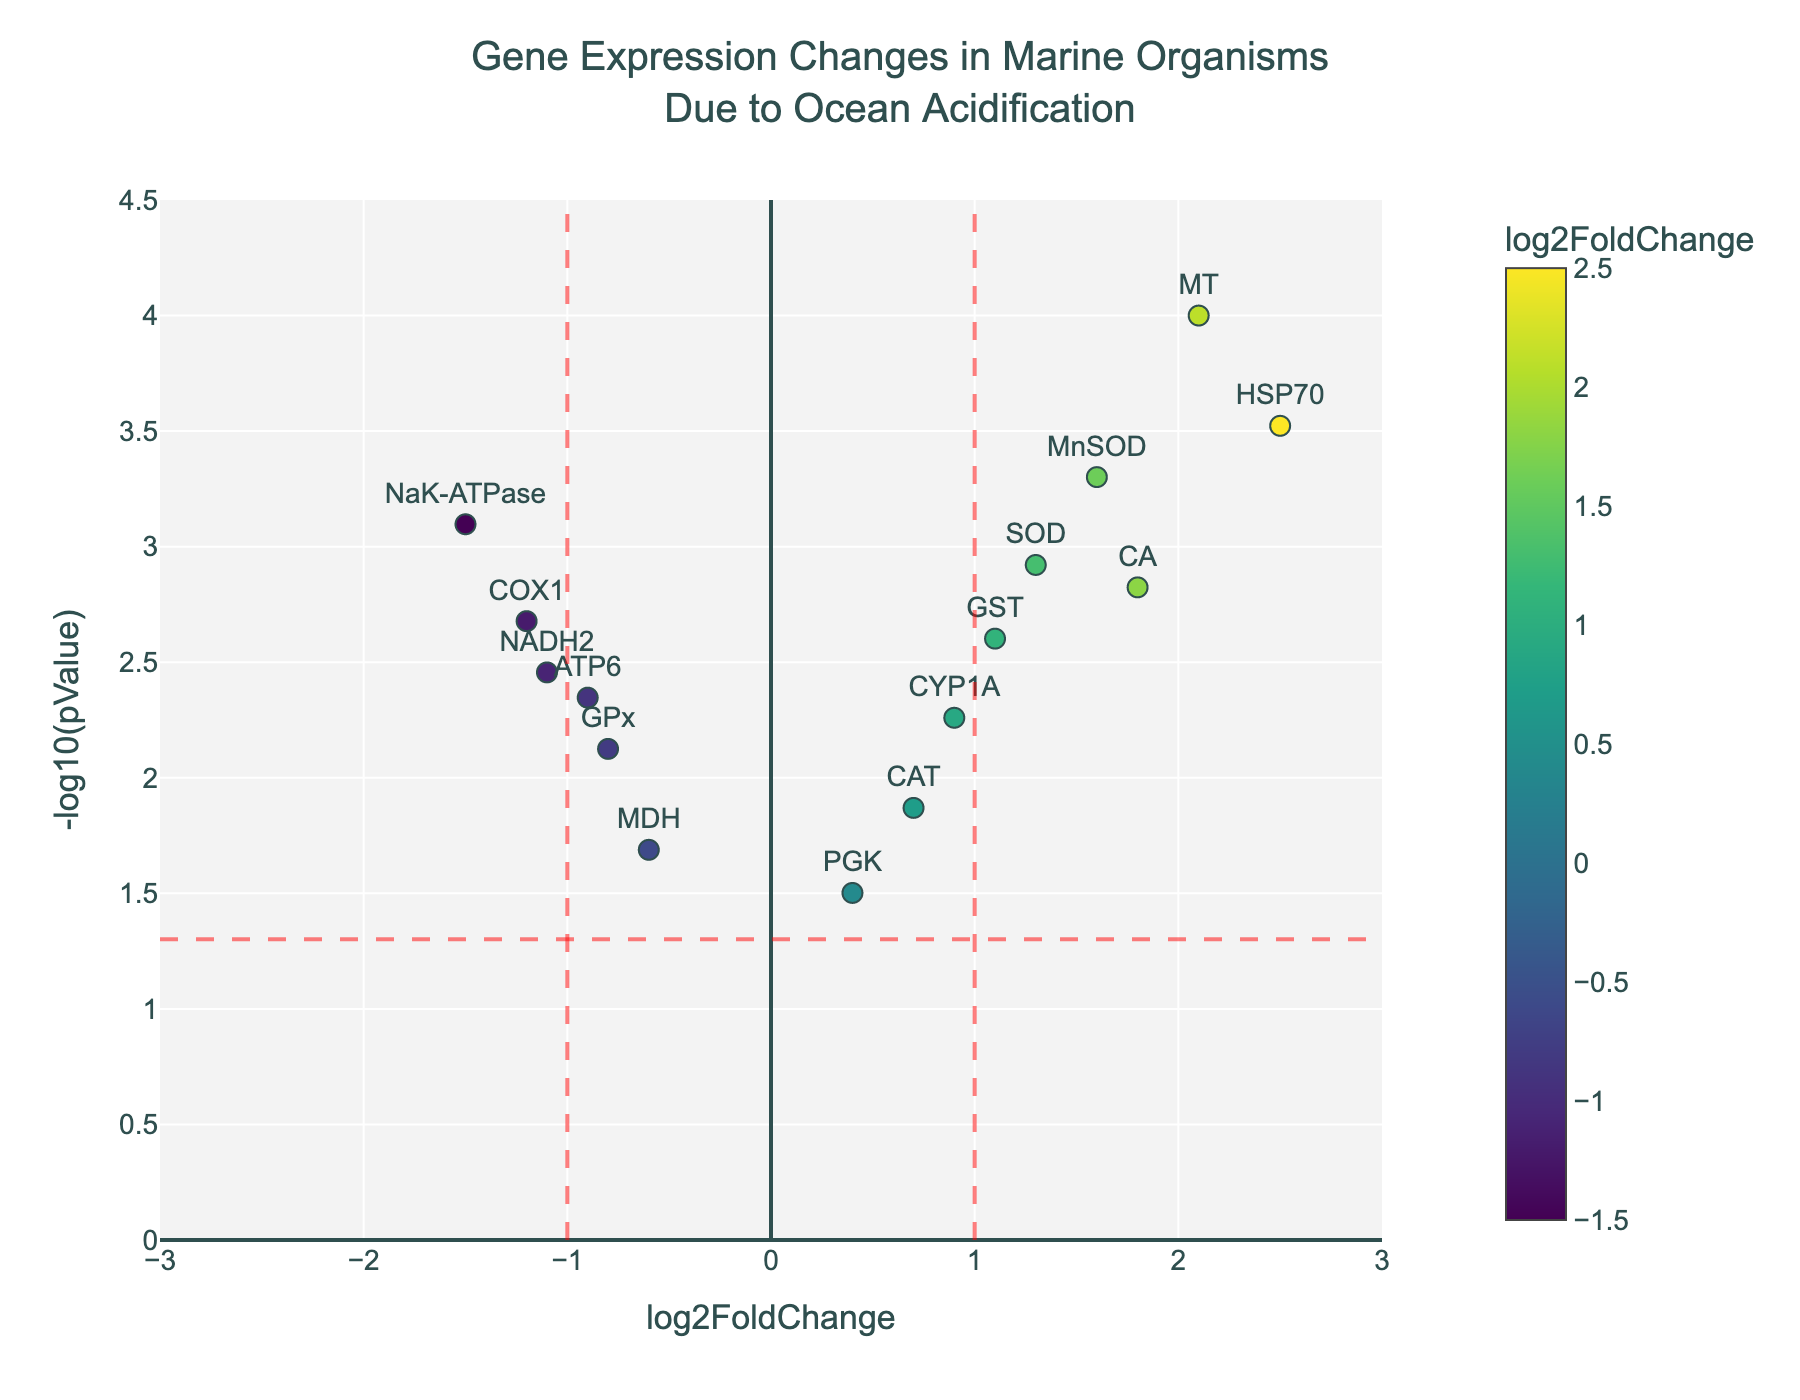What's the title of the figure? The title is located at the top of the figure and reads "Gene Expression Changes in Marine Organisms<br>Due to Ocean Acidification".
Answer: Gene Expression Changes in Marine Organisms<br>Due to Ocean Acidification What does the x-axis represent? The x-axis is labeled as "log2FoldChange" at the bottom of the figure.
Answer: log2FoldChange What does the y-axis represent? The y-axis is labeled as "-log10(pValue)" on the left side of the figure.
Answer: -log10(pValue) Which genes have a log2FoldChange greater than 2 and are statistically significant (p-value < 0.05)? To answer this question, find points on the figure with log2FoldChange values greater than 2 and p-values less than 0.05, represented above the horizontal red dashed line.
Answer: HSP70, MT How many genes have a log2FoldChange less than -1 and a p-value less than 0.05? Count the number of data points on the figure with a log2FoldChange less than -1 (left of the vertical red dashed line) and above the horizontal red dashed line.
Answer: 3 Between SOD and NaK-ATPase, which gene has a more significant p-value (smaller value)? Compare the y-axis values (-log10(pValue)) for SOD and NaK-ATPase. The one with the higher y-axis value has a smaller p-value.
Answer: SOD What is the log2FoldChange of the gene with the smallest p-value? Identify the gene with the highest y-axis value (-log10(pValue)), then check its corresponding x-axis value for log2FoldChange.
Answer: 2.1 (MT gene) How many genes have a log2FoldChange between -1 and 1 and a p-value greater than 0.05? Look for data points within the range of -1 to 1 on the x-axis and below the horizontal red dashed line on the y-axis.
Answer: 2 Which gene has the highest log2FoldChange? Identify the gene that is farthest to the right on the x-axis.
Answer: HSP70 What is the range of p-values represented on the y-axis? Identify the minimum and the maximum y values and translate those back to p-values using the -log10 scale.
Answer: 0.0001 to 0.0315 